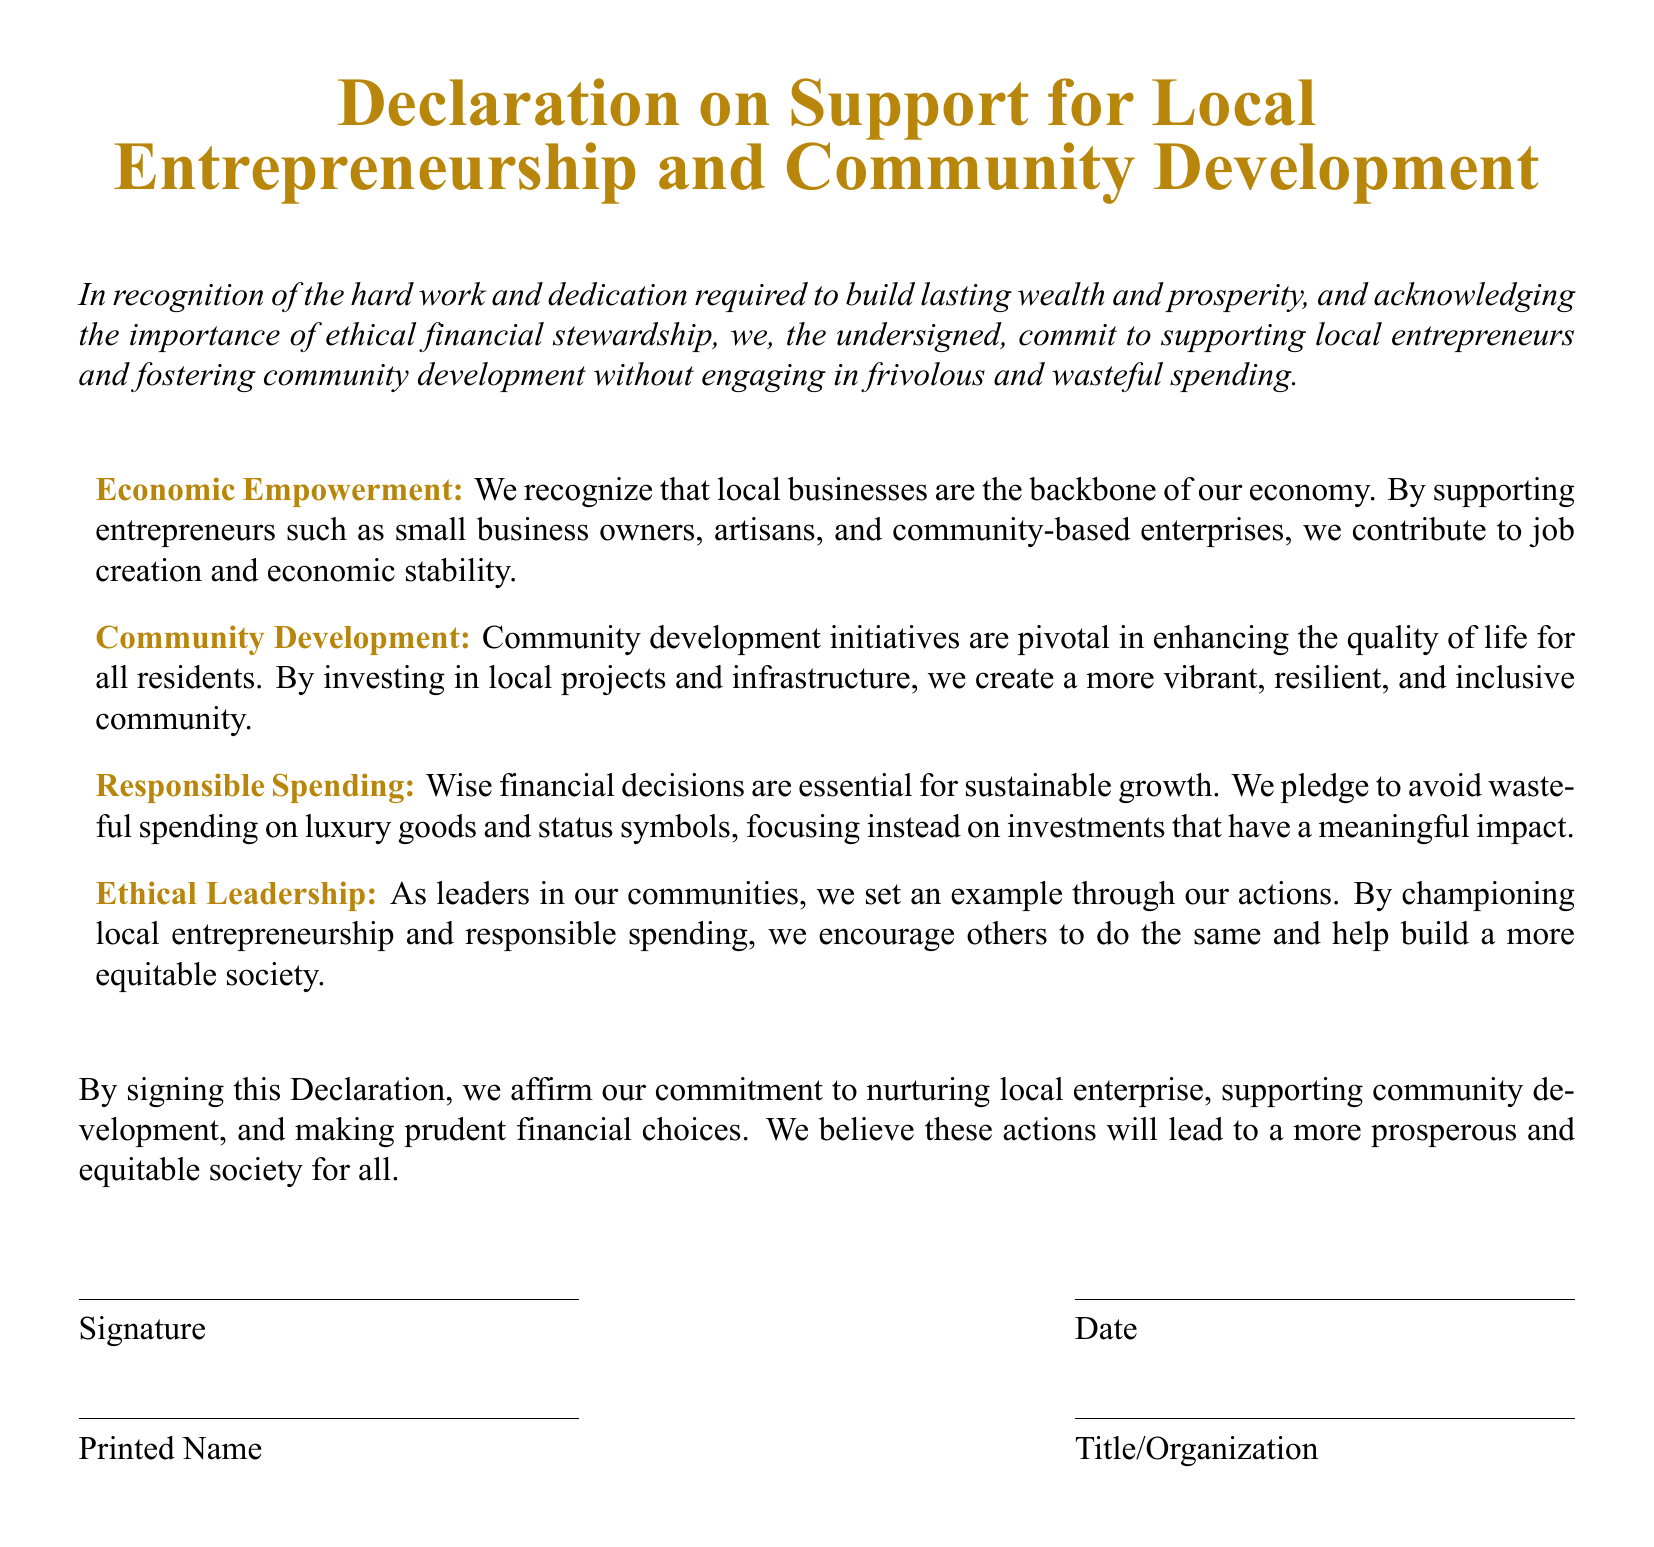What is the title of the document? The title is clearly stated at the beginning of the document in a large font.
Answer: Declaration on Support for Local Entrepreneurship and Community Development What is committed to in this Declaration? The main commitment is outlined in the introduction where the undersigned pledge to support local entrepreneurs.
Answer: Supporting local entrepreneurs What are local businesses recognized as? The document identifies local businesses as essential for the economy.
Answer: Backbone of our economy What type of spending is avoided according to the Declaration? The Declaration emphasizes avoiding specific types of financial expenditures.
Answer: Wasteful spending How many key areas of focus does the Declaration mention? The document highlights different aspects that signify its focus areas that are numbered.
Answer: Four What is the purpose of community development initiatives according to the Declaration? The document specifies the goal of community initiatives in terms of community benefit.
Answer: Enhancing quality of life What do the signers affirm by signing the Declaration? The document mentions a specific action that the signers endorse by signing it.
Answer: Commitment to nurturing local enterprise What color is used for emphasis throughout the document? The document features a specific color that is repeated for headings and text elements.
Answer: Dark gold 